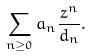<formula> <loc_0><loc_0><loc_500><loc_500>\sum _ { n \geq 0 } a _ { n } \frac { z ^ { n } } { d _ { n } } .</formula> 